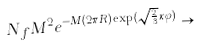<formula> <loc_0><loc_0><loc_500><loc_500>N _ { f } M ^ { 2 } e ^ { - M ( 2 \pi R ) \exp ( \sqrt { \frac { 2 } { 3 } } \kappa \varphi ) } \rightarrow</formula> 